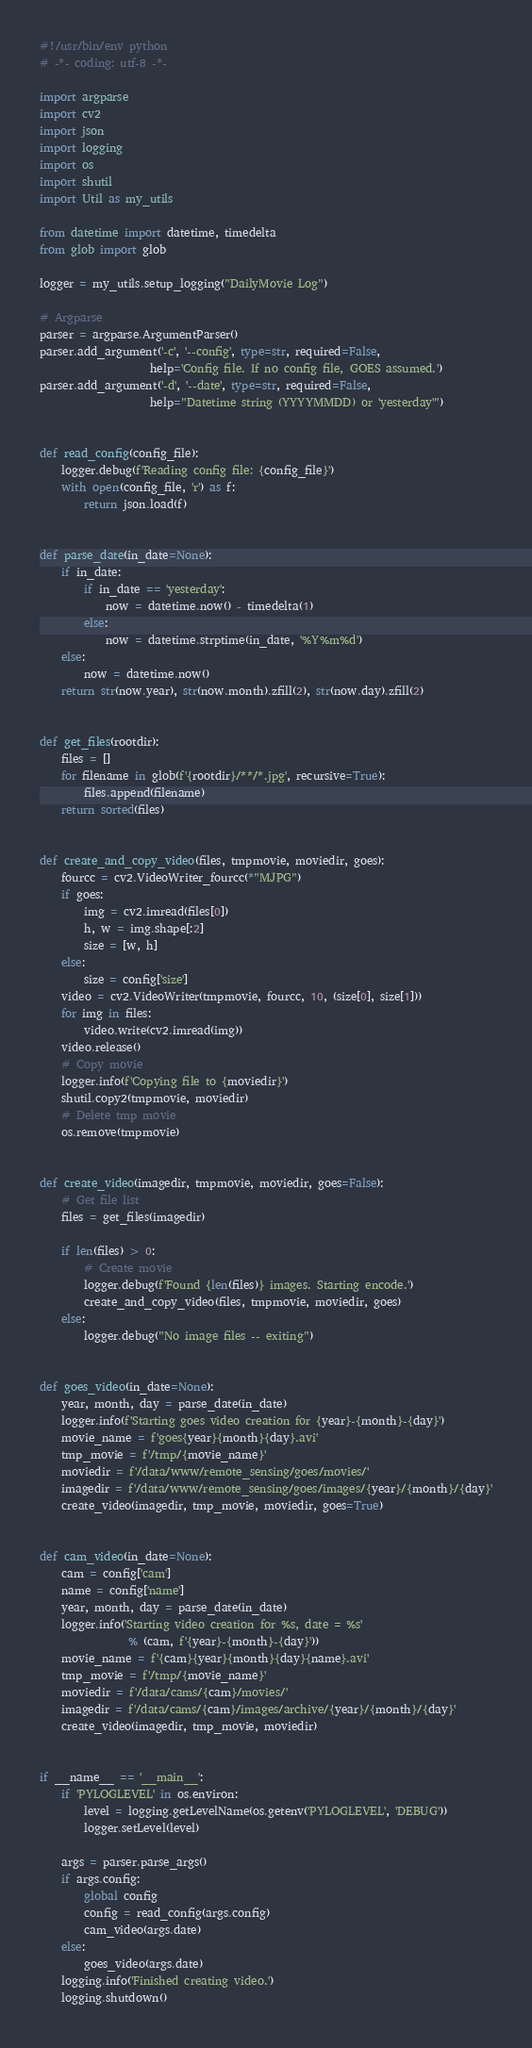<code> <loc_0><loc_0><loc_500><loc_500><_Python_>#!/usr/bin/env python
# -*- coding: utf-8 -*-

import argparse
import cv2
import json
import logging
import os
import shutil
import Util as my_utils

from datetime import datetime, timedelta
from glob import glob

logger = my_utils.setup_logging("DailyMovie Log")

# Argparse
parser = argparse.ArgumentParser()
parser.add_argument('-c', '--config', type=str, required=False,
                    help='Config file. If no config file, GOES assumed.')
parser.add_argument('-d', '--date', type=str, required=False,
                    help="Datetime string (YYYYMMDD) or 'yesterday'")


def read_config(config_file):
    logger.debug(f'Reading config file: {config_file}')
    with open(config_file, 'r') as f:
        return json.load(f)


def parse_date(in_date=None):
    if in_date:
        if in_date == 'yesterday':
            now = datetime.now() - timedelta(1)
        else:
            now = datetime.strptime(in_date, '%Y%m%d')
    else:
        now = datetime.now()
    return str(now.year), str(now.month).zfill(2), str(now.day).zfill(2)


def get_files(rootdir):
    files = []
    for filename in glob(f'{rootdir}/**/*.jpg', recursive=True):
        files.append(filename)
    return sorted(files)


def create_and_copy_video(files, tmpmovie, moviedir, goes):
    fourcc = cv2.VideoWriter_fourcc(*"MJPG")
    if goes:
        img = cv2.imread(files[0])
        h, w = img.shape[:2]
        size = [w, h]
    else:
        size = config['size']
    video = cv2.VideoWriter(tmpmovie, fourcc, 10, (size[0], size[1]))
    for img in files:
        video.write(cv2.imread(img))
    video.release()
    # Copy movie
    logger.info(f'Copying file to {moviedir}')
    shutil.copy2(tmpmovie, moviedir)
    # Delete tmp movie
    os.remove(tmpmovie)


def create_video(imagedir, tmpmovie, moviedir, goes=False):
    # Get file list
    files = get_files(imagedir)

    if len(files) > 0:
        # Create movie
        logger.debug(f'Found {len(files)} images. Starting encode.')
        create_and_copy_video(files, tmpmovie, moviedir, goes)
    else:
        logger.debug("No image files -- exiting")


def goes_video(in_date=None):
    year, month, day = parse_date(in_date)
    logger.info(f'Starting goes video creation for {year}-{month}-{day}')
    movie_name = f'goes{year}{month}{day}.avi'
    tmp_movie = f'/tmp/{movie_name}'
    moviedir = f'/data/www/remote_sensing/goes/movies/'
    imagedir = f'/data/www/remote_sensing/goes/images/{year}/{month}/{day}'
    create_video(imagedir, tmp_movie, moviedir, goes=True)


def cam_video(in_date=None):
    cam = config['cam']
    name = config['name']
    year, month, day = parse_date(in_date)
    logger.info('Starting video creation for %s, date = %s'
                % (cam, f'{year}-{month}-{day}'))
    movie_name = f'{cam}{year}{month}{day}{name}.avi'
    tmp_movie = f'/tmp/{movie_name}'
    moviedir = f'/data/cams/{cam}/movies/'
    imagedir = f'/data/cams/{cam}/images/archive/{year}/{month}/{day}'
    create_video(imagedir, tmp_movie, moviedir)


if __name__ == '__main__':
    if 'PYLOGLEVEL' in os.environ:
        level = logging.getLevelName(os.getenv('PYLOGLEVEL', 'DEBUG'))
        logger.setLevel(level)

    args = parser.parse_args()
    if args.config:
        global config
        config = read_config(args.config)
        cam_video(args.date)
    else:
        goes_video(args.date)
    logging.info('Finished creating video.')
    logging.shutdown()
</code> 